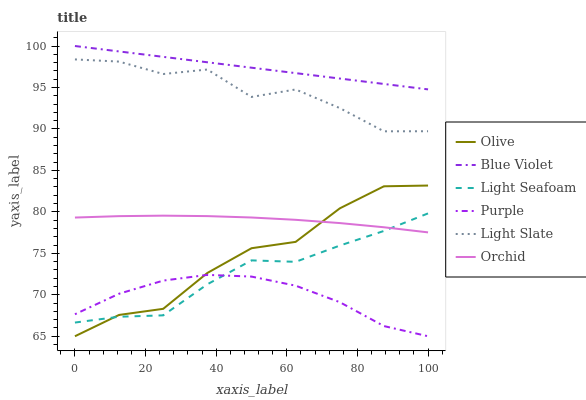Does Purple have the minimum area under the curve?
Answer yes or no. Yes. Does Blue Violet have the maximum area under the curve?
Answer yes or no. Yes. Does Light Slate have the minimum area under the curve?
Answer yes or no. No. Does Light Slate have the maximum area under the curve?
Answer yes or no. No. Is Blue Violet the smoothest?
Answer yes or no. Yes. Is Light Slate the roughest?
Answer yes or no. Yes. Is Olive the smoothest?
Answer yes or no. No. Is Olive the roughest?
Answer yes or no. No. Does Purple have the lowest value?
Answer yes or no. Yes. Does Light Slate have the lowest value?
Answer yes or no. No. Does Blue Violet have the highest value?
Answer yes or no. Yes. Does Light Slate have the highest value?
Answer yes or no. No. Is Olive less than Blue Violet?
Answer yes or no. Yes. Is Blue Violet greater than Olive?
Answer yes or no. Yes. Does Light Seafoam intersect Orchid?
Answer yes or no. Yes. Is Light Seafoam less than Orchid?
Answer yes or no. No. Is Light Seafoam greater than Orchid?
Answer yes or no. No. Does Olive intersect Blue Violet?
Answer yes or no. No. 